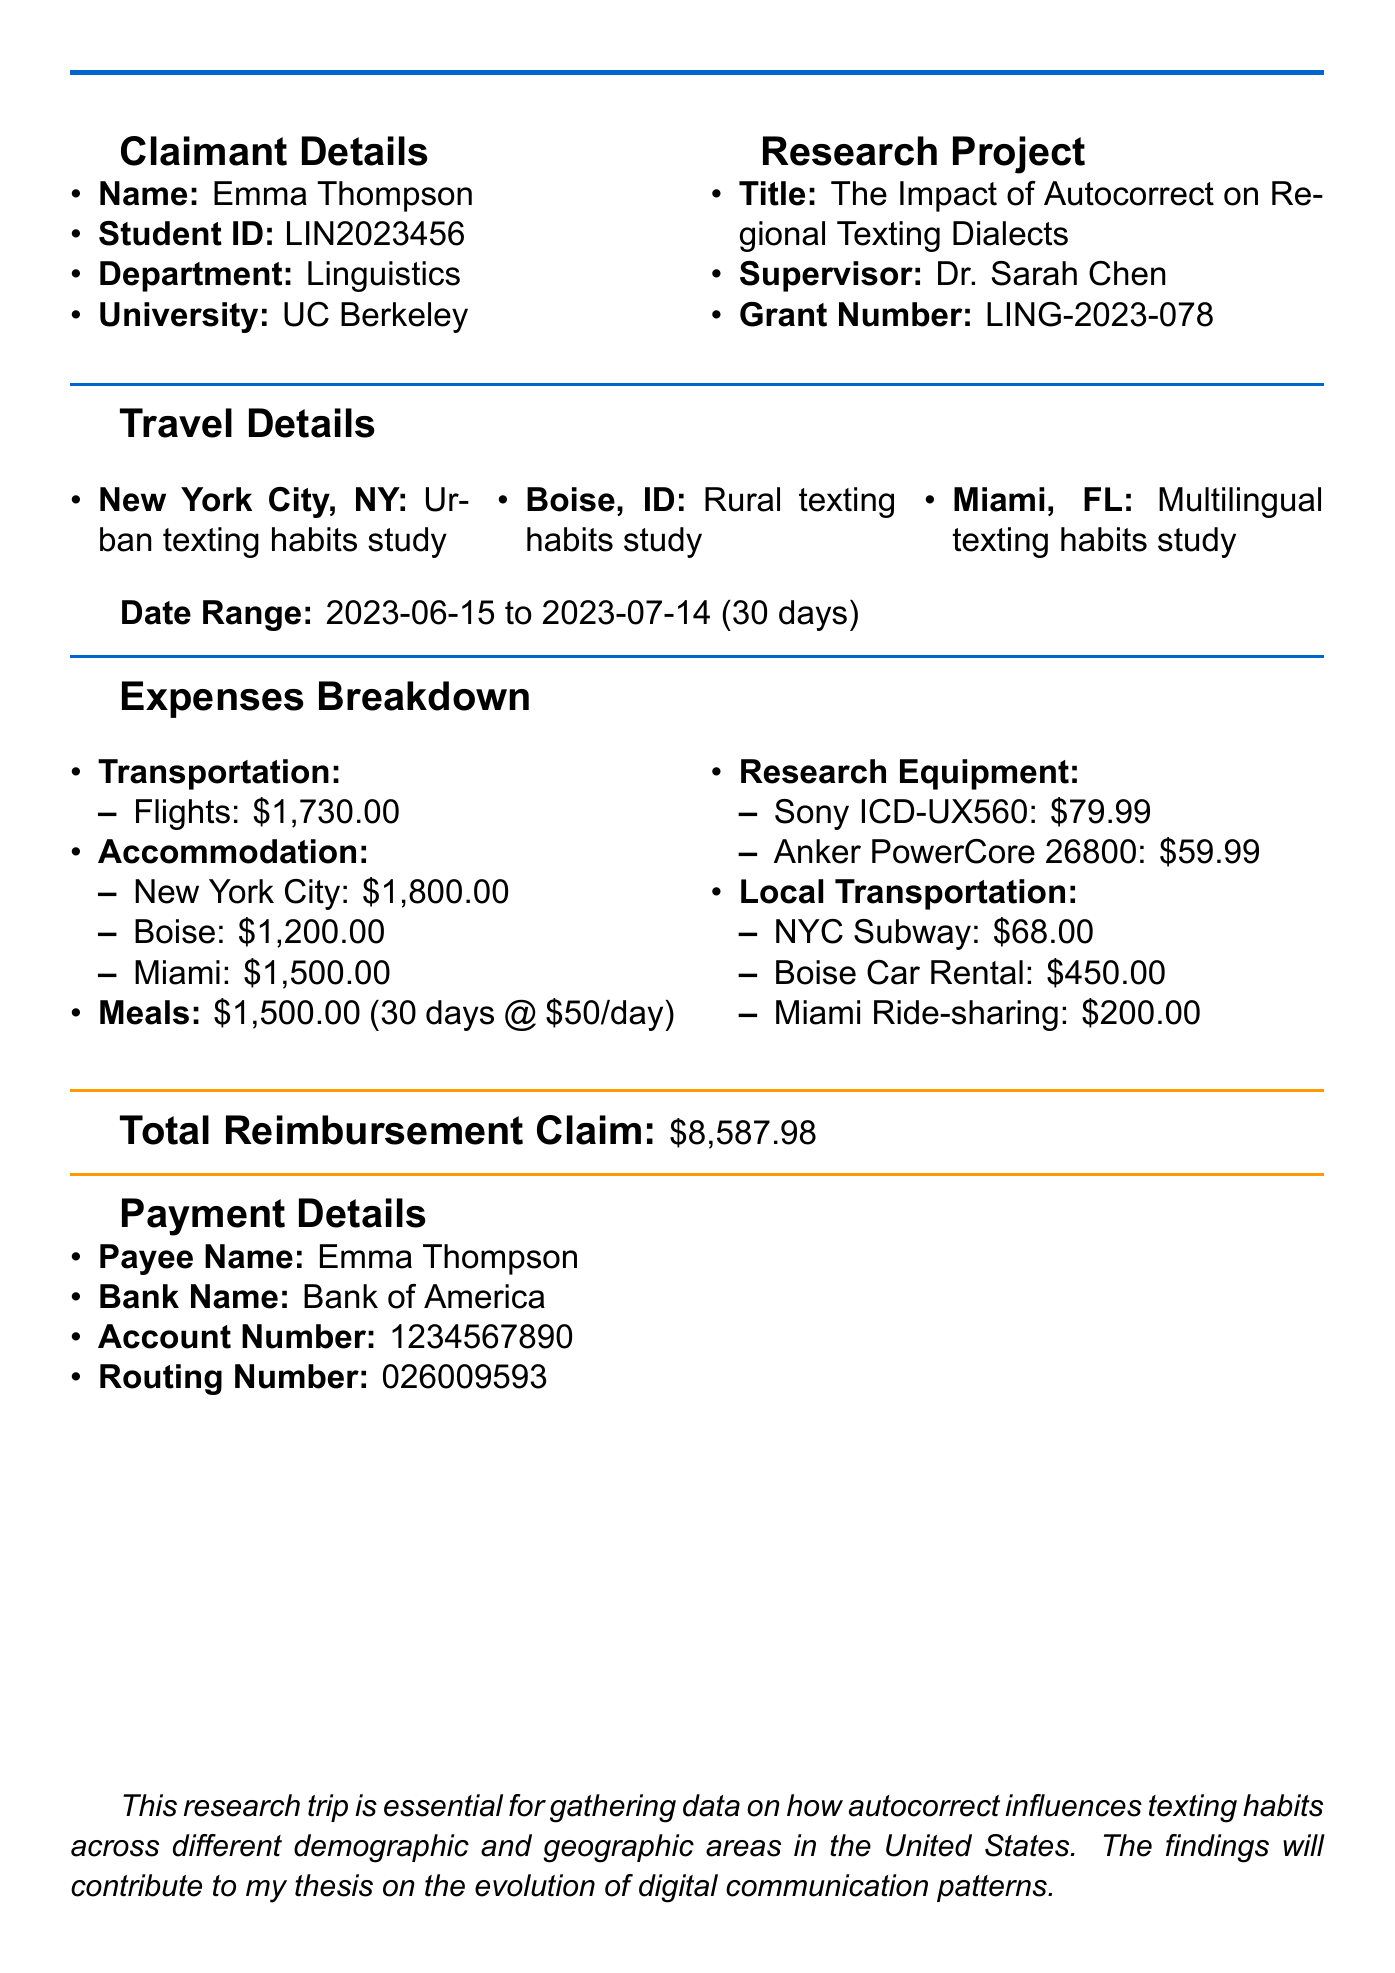What is the name of the claimant? The claimant's name is explicitly stated in the document under the claimant details.
Answer: Emma Thompson What is the total reimbursement claim amount? The total reimbursement claim is clearly presented in the expenses breakdown section.
Answer: $8,587.98 What is the purpose of the New York City trip? The purpose of the trip is specified for each destination in the travel details section.
Answer: Urban texting habits study How many nights did Emma stay in Boise? The number of nights stayed in Boise is detailed in the accommodation section.
Answer: 10 Who is the supervisor of the research project? The supervisor's name is listed in the research project section of the document.
Answer: Dr. Sarah Chen What type of local transportation was used in Miami? The type of local transportation is mentioned alongside the corresponding costs in the local transportation details.
Answer: Ride-sharing How many days in total was the research trip? The total duration of the research trip is explicitly stated in the travel details section.
Answer: 30 What hotel did Emma stay at in New York City? The hotel name is mentioned in the accommodation details for New York City.
Answer: Hampton Inn Manhattan/Times Square Central What is the daily meal allowance? The daily meal allowance is specified in the meals section of the expenses.
Answer: $50.00 What research equipment was purchased? The items categorized under research equipment are detailed in the expenses breakdown.
Answer: Portable voice recorder, External battery pack 